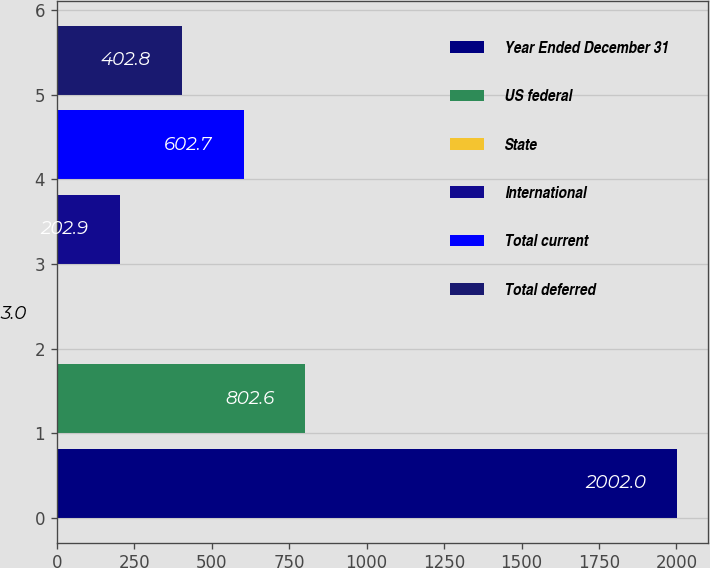Convert chart. <chart><loc_0><loc_0><loc_500><loc_500><bar_chart><fcel>Year Ended December 31<fcel>US federal<fcel>State<fcel>International<fcel>Total current<fcel>Total deferred<nl><fcel>2002<fcel>802.6<fcel>3<fcel>202.9<fcel>602.7<fcel>402.8<nl></chart> 